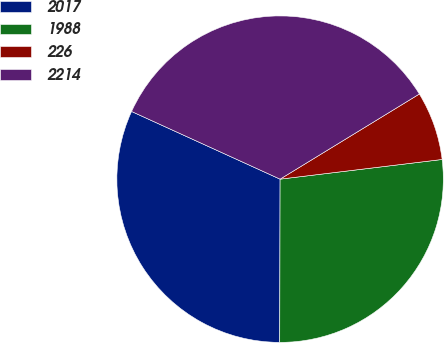Convert chart to OTSL. <chart><loc_0><loc_0><loc_500><loc_500><pie_chart><fcel>2017<fcel>1988<fcel>226<fcel>2214<nl><fcel>31.77%<fcel>26.96%<fcel>6.81%<fcel>34.46%<nl></chart> 